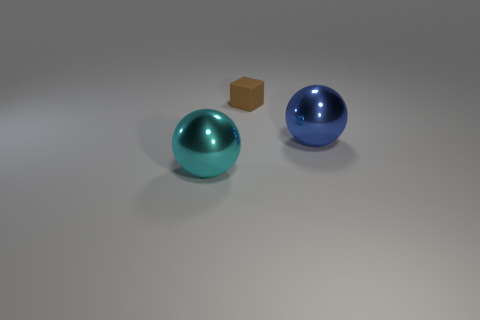Add 2 tiny yellow rubber objects. How many objects exist? 5 Subtract all blocks. How many objects are left? 2 Add 3 blue shiny spheres. How many blue shiny spheres are left? 4 Add 2 red blocks. How many red blocks exist? 2 Subtract 0 red cylinders. How many objects are left? 3 Subtract all yellow rubber spheres. Subtract all small brown things. How many objects are left? 2 